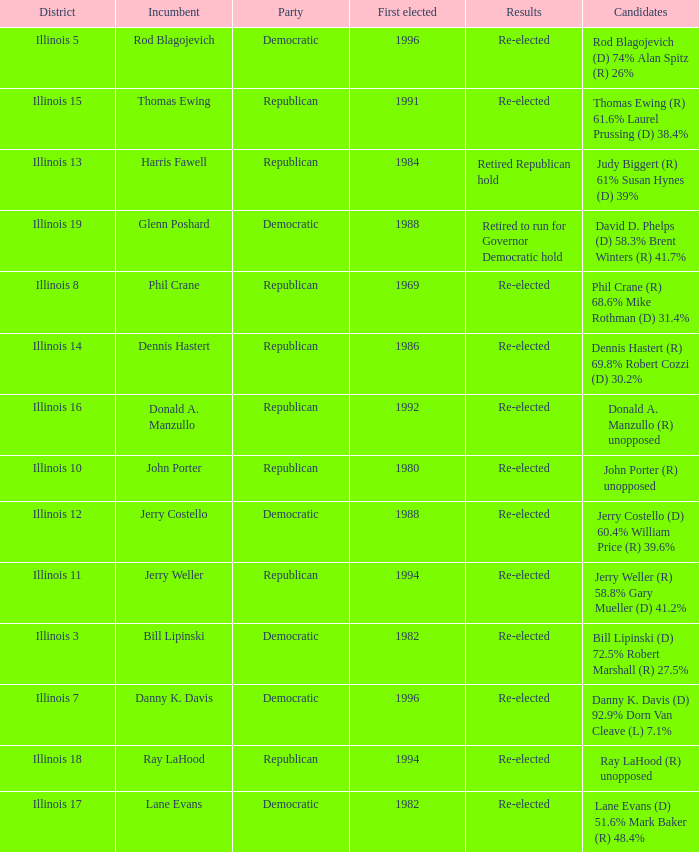What was the result in Illinois 7? Re-elected. 